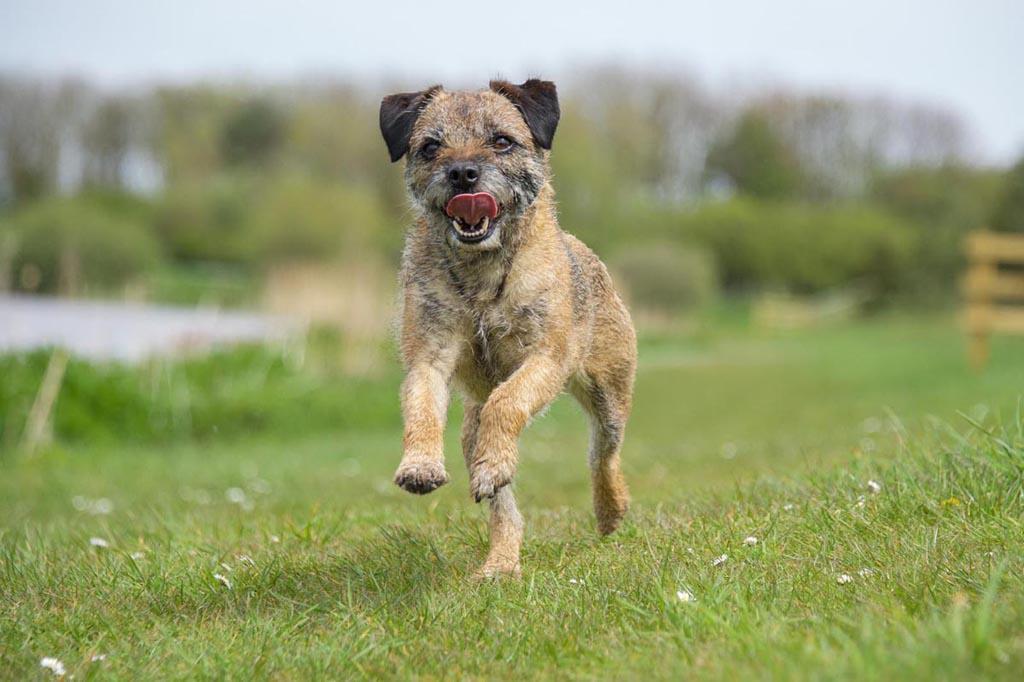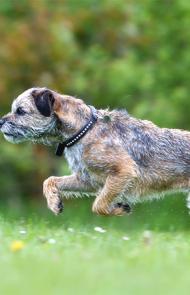The first image is the image on the left, the second image is the image on the right. Analyze the images presented: Is the assertion "The dog in the image on the right is not running." valid? Answer yes or no. No. The first image is the image on the left, the second image is the image on the right. For the images shown, is this caption "Both images show a dog running in the grass." true? Answer yes or no. Yes. 